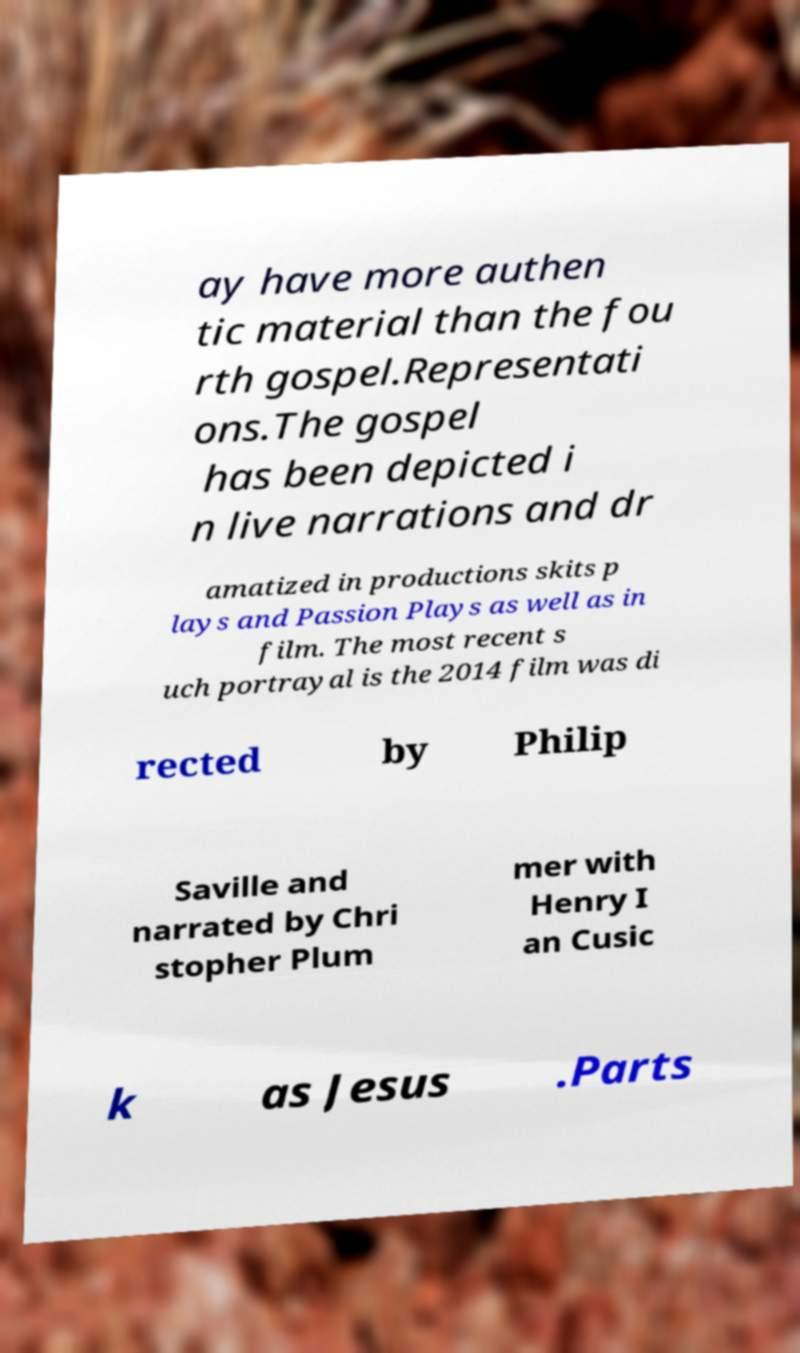Can you read and provide the text displayed in the image?This photo seems to have some interesting text. Can you extract and type it out for me? ay have more authen tic material than the fou rth gospel.Representati ons.The gospel has been depicted i n live narrations and dr amatized in productions skits p lays and Passion Plays as well as in film. The most recent s uch portrayal is the 2014 film was di rected by Philip Saville and narrated by Chri stopher Plum mer with Henry I an Cusic k as Jesus .Parts 